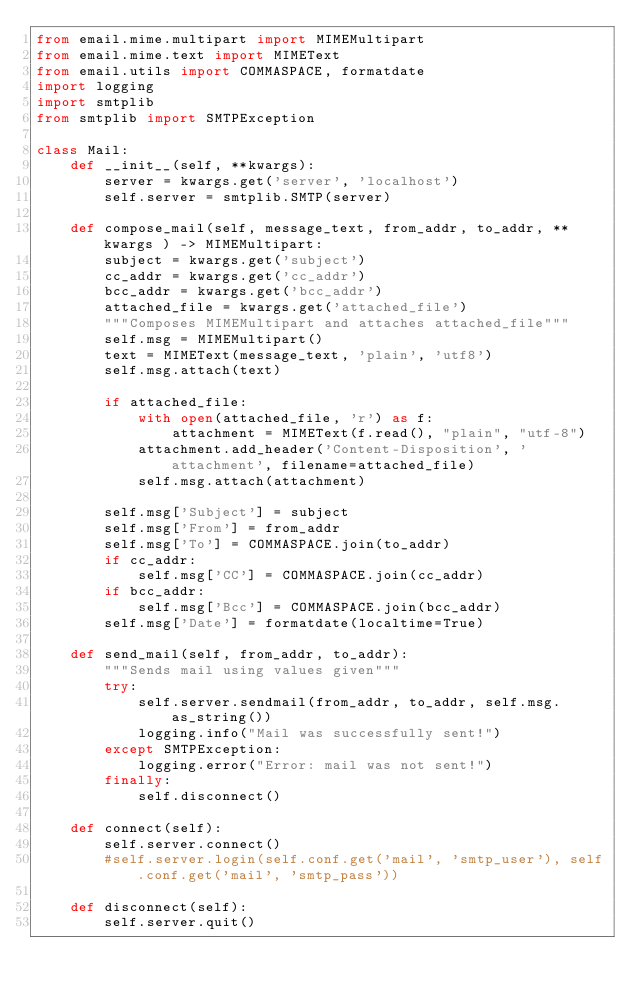Convert code to text. <code><loc_0><loc_0><loc_500><loc_500><_Python_>from email.mime.multipart import MIMEMultipart
from email.mime.text import MIMEText
from email.utils import COMMASPACE, formatdate
import logging
import smtplib
from smtplib import SMTPException

class Mail:
    def __init__(self, **kwargs):
        server = kwargs.get('server', 'localhost')
        self.server = smtplib.SMTP(server)

    def compose_mail(self, message_text, from_addr, to_addr, **kwargs ) -> MIMEMultipart:
        subject = kwargs.get('subject')
        cc_addr = kwargs.get('cc_addr')
        bcc_addr = kwargs.get('bcc_addr')
        attached_file = kwargs.get('attached_file')
        """Composes MIMEMultipart and attaches attached_file"""
        self.msg = MIMEMultipart()
        text = MIMEText(message_text, 'plain', 'utf8')
        self.msg.attach(text)

        if attached_file:
            with open(attached_file, 'r') as f:
                attachment = MIMEText(f.read(), "plain", "utf-8")
            attachment.add_header('Content-Disposition', 'attachment', filename=attached_file)
            self.msg.attach(attachment)

        self.msg['Subject'] = subject
        self.msg['From'] = from_addr
        self.msg['To'] = COMMASPACE.join(to_addr)
        if cc_addr:
            self.msg['CC'] = COMMASPACE.join(cc_addr)
        if bcc_addr:
            self.msg['Bcc'] = COMMASPACE.join(bcc_addr)
        self.msg['Date'] = formatdate(localtime=True)

    def send_mail(self, from_addr, to_addr):
        """Sends mail using values given"""
        try:
            self.server.sendmail(from_addr, to_addr, self.msg.as_string())
            logging.info("Mail was successfully sent!")
        except SMTPException:
            logging.error("Error: mail was not sent!")
        finally:
            self.disconnect()

    def connect(self):
        self.server.connect()
        #self.server.login(self.conf.get('mail', 'smtp_user'), self.conf.get('mail', 'smtp_pass'))

    def disconnect(self):
        self.server.quit()

 
</code> 